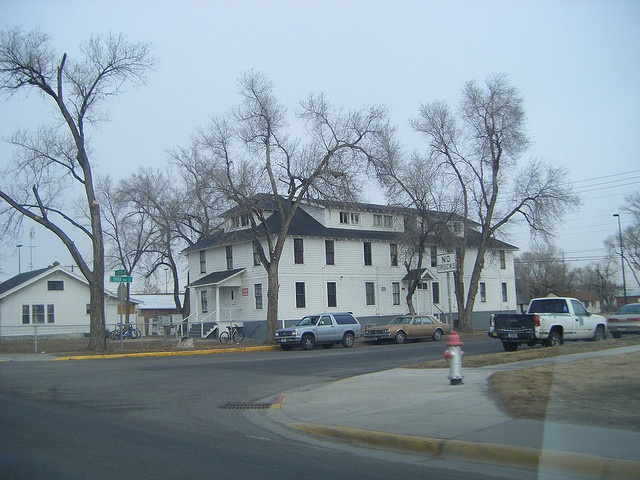Describe the objects in this image and their specific colors. I can see truck in lightblue, black, darkgray, navy, and gray tones, car in lightblue, gray, black, and darkgray tones, car in lightblue, gray, black, and darkgray tones, fire hydrant in lightblue, darkgray, gray, and brown tones, and car in lightblue, gray, blue, and black tones in this image. 